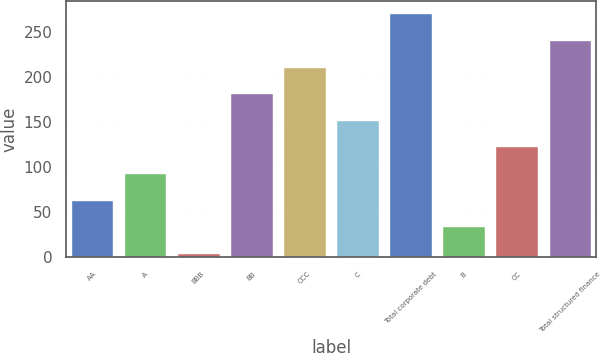Convert chart. <chart><loc_0><loc_0><loc_500><loc_500><bar_chart><fcel>AA<fcel>A<fcel>BBB<fcel>BB<fcel>CCC<fcel>C<fcel>Total corporate debt<fcel>B<fcel>CC<fcel>Total structured finance<nl><fcel>64.1<fcel>93.65<fcel>5<fcel>182.3<fcel>211.85<fcel>152.75<fcel>270.95<fcel>34.55<fcel>123.2<fcel>241.4<nl></chart> 